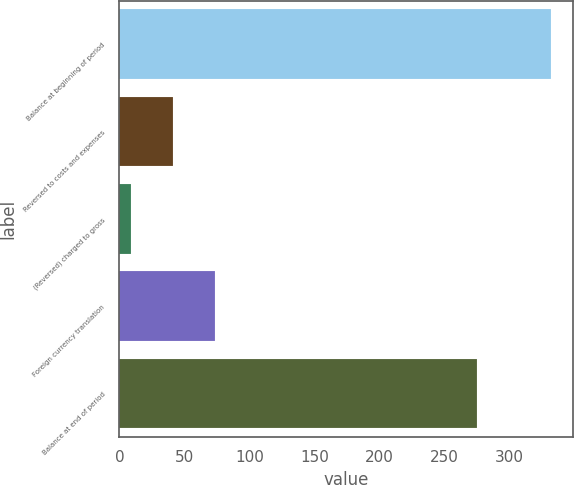Convert chart. <chart><loc_0><loc_0><loc_500><loc_500><bar_chart><fcel>Balance at beginning of period<fcel>Reversed to costs and expenses<fcel>(Reversed) charged to gross<fcel>Foreign currency translation<fcel>Balance at end of period<nl><fcel>332.2<fcel>41.5<fcel>9.2<fcel>73.8<fcel>275.1<nl></chart> 